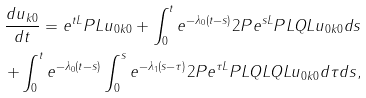Convert formula to latex. <formula><loc_0><loc_0><loc_500><loc_500>\frac { d u _ { k 0 } } { d t } = e ^ { t L } P L u _ { 0 k 0 } + \int _ { 0 } ^ { t } e ^ { - \lambda _ { 0 } ( t - s ) } 2 P e ^ { s L } P L Q L u _ { 0 k 0 } d s \\ + \int _ { 0 } ^ { t } e ^ { - \lambda _ { 0 } ( t - s ) } \int _ { 0 } ^ { s } e ^ { - \lambda _ { 1 } ( s - \tau ) } 2 P e ^ { \tau L } P L Q L Q L u _ { 0 k 0 } d \tau d s ,</formula> 